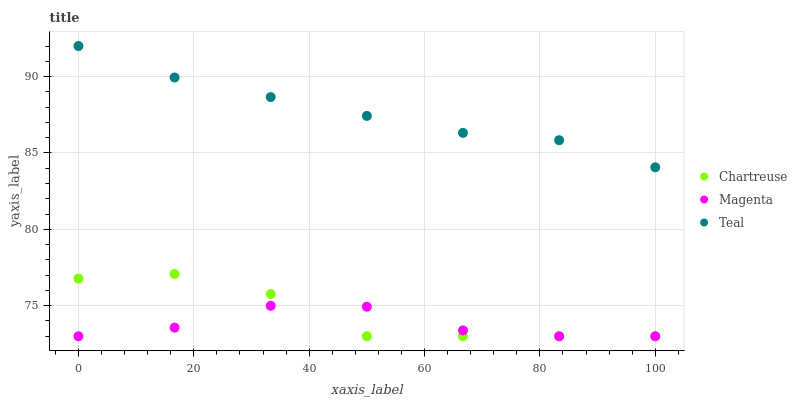Does Magenta have the minimum area under the curve?
Answer yes or no. Yes. Does Teal have the maximum area under the curve?
Answer yes or no. Yes. Does Teal have the minimum area under the curve?
Answer yes or no. No. Does Magenta have the maximum area under the curve?
Answer yes or no. No. Is Teal the smoothest?
Answer yes or no. Yes. Is Chartreuse the roughest?
Answer yes or no. Yes. Is Magenta the smoothest?
Answer yes or no. No. Is Magenta the roughest?
Answer yes or no. No. Does Chartreuse have the lowest value?
Answer yes or no. Yes. Does Teal have the lowest value?
Answer yes or no. No. Does Teal have the highest value?
Answer yes or no. Yes. Does Magenta have the highest value?
Answer yes or no. No. Is Chartreuse less than Teal?
Answer yes or no. Yes. Is Teal greater than Magenta?
Answer yes or no. Yes. Does Chartreuse intersect Magenta?
Answer yes or no. Yes. Is Chartreuse less than Magenta?
Answer yes or no. No. Is Chartreuse greater than Magenta?
Answer yes or no. No. Does Chartreuse intersect Teal?
Answer yes or no. No. 